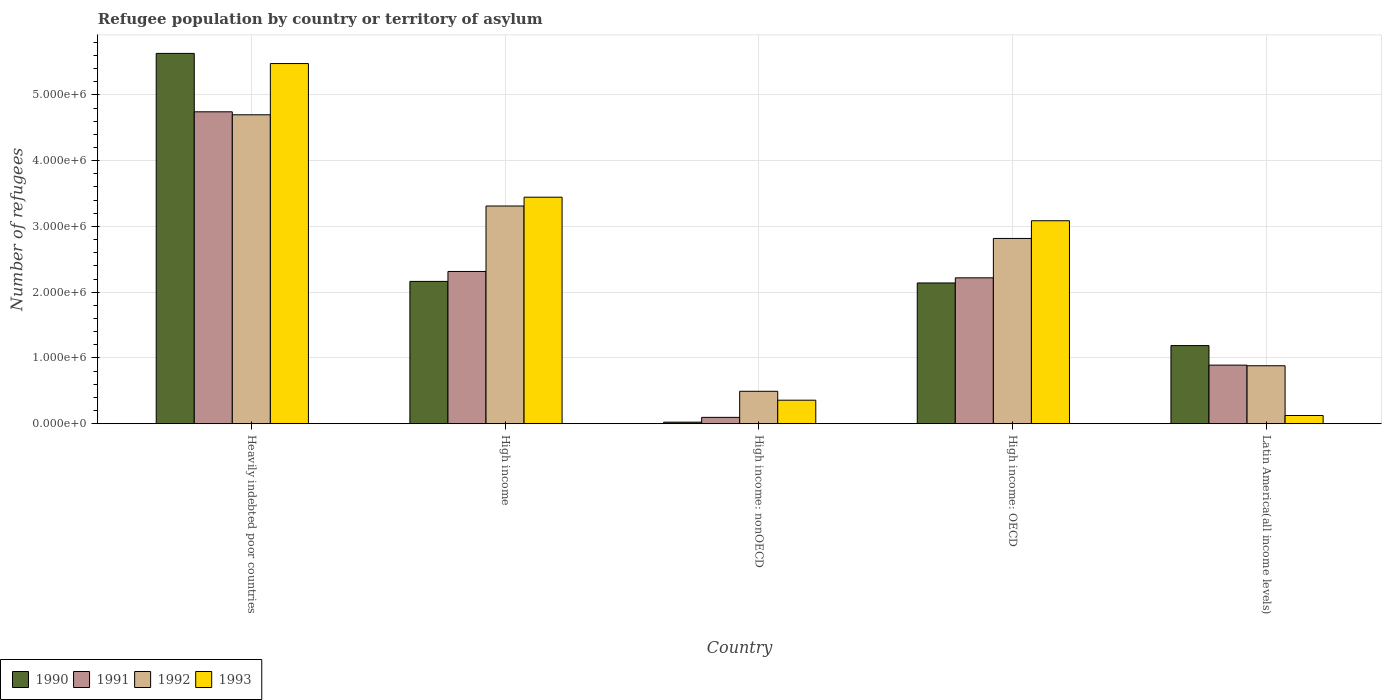Are the number of bars per tick equal to the number of legend labels?
Ensure brevity in your answer.  Yes. What is the label of the 1st group of bars from the left?
Ensure brevity in your answer.  Heavily indebted poor countries. In how many cases, is the number of bars for a given country not equal to the number of legend labels?
Your response must be concise. 0. What is the number of refugees in 1992 in Latin America(all income levels)?
Keep it short and to the point. 8.82e+05. Across all countries, what is the maximum number of refugees in 1992?
Provide a short and direct response. 4.70e+06. Across all countries, what is the minimum number of refugees in 1992?
Provide a short and direct response. 4.93e+05. In which country was the number of refugees in 1992 maximum?
Your answer should be very brief. Heavily indebted poor countries. In which country was the number of refugees in 1990 minimum?
Your answer should be compact. High income: nonOECD. What is the total number of refugees in 1991 in the graph?
Make the answer very short. 1.03e+07. What is the difference between the number of refugees in 1992 in High income: OECD and that in Latin America(all income levels)?
Offer a terse response. 1.94e+06. What is the difference between the number of refugees in 1990 in High income and the number of refugees in 1991 in Heavily indebted poor countries?
Ensure brevity in your answer.  -2.58e+06. What is the average number of refugees in 1991 per country?
Your answer should be very brief. 2.05e+06. What is the difference between the number of refugees of/in 1993 and number of refugees of/in 1991 in Heavily indebted poor countries?
Provide a short and direct response. 7.34e+05. In how many countries, is the number of refugees in 1993 greater than 1600000?
Your answer should be compact. 3. What is the ratio of the number of refugees in 1990 in High income: nonOECD to that in Latin America(all income levels)?
Your answer should be very brief. 0.02. Is the number of refugees in 1990 in High income: OECD less than that in High income: nonOECD?
Make the answer very short. No. What is the difference between the highest and the second highest number of refugees in 1991?
Ensure brevity in your answer.  -2.52e+06. What is the difference between the highest and the lowest number of refugees in 1992?
Offer a very short reply. 4.20e+06. Is the sum of the number of refugees in 1992 in High income: OECD and Latin America(all income levels) greater than the maximum number of refugees in 1990 across all countries?
Give a very brief answer. No. Is it the case that in every country, the sum of the number of refugees in 1993 and number of refugees in 1992 is greater than the sum of number of refugees in 1990 and number of refugees in 1991?
Ensure brevity in your answer.  No. What does the 1st bar from the left in High income: OECD represents?
Keep it short and to the point. 1990. Is it the case that in every country, the sum of the number of refugees in 1993 and number of refugees in 1991 is greater than the number of refugees in 1990?
Your answer should be very brief. No. Are all the bars in the graph horizontal?
Provide a succinct answer. No. How many countries are there in the graph?
Offer a terse response. 5. What is the difference between two consecutive major ticks on the Y-axis?
Provide a succinct answer. 1.00e+06. How many legend labels are there?
Provide a short and direct response. 4. How are the legend labels stacked?
Offer a terse response. Horizontal. What is the title of the graph?
Your answer should be compact. Refugee population by country or territory of asylum. Does "1995" appear as one of the legend labels in the graph?
Ensure brevity in your answer.  No. What is the label or title of the X-axis?
Provide a succinct answer. Country. What is the label or title of the Y-axis?
Ensure brevity in your answer.  Number of refugees. What is the Number of refugees of 1990 in Heavily indebted poor countries?
Your answer should be compact. 5.63e+06. What is the Number of refugees in 1991 in Heavily indebted poor countries?
Give a very brief answer. 4.74e+06. What is the Number of refugees of 1992 in Heavily indebted poor countries?
Your answer should be very brief. 4.70e+06. What is the Number of refugees of 1993 in Heavily indebted poor countries?
Ensure brevity in your answer.  5.48e+06. What is the Number of refugees of 1990 in High income?
Give a very brief answer. 2.16e+06. What is the Number of refugees of 1991 in High income?
Your answer should be compact. 2.32e+06. What is the Number of refugees in 1992 in High income?
Offer a terse response. 3.31e+06. What is the Number of refugees of 1993 in High income?
Provide a succinct answer. 3.44e+06. What is the Number of refugees of 1990 in High income: nonOECD?
Your answer should be very brief. 2.39e+04. What is the Number of refugees in 1991 in High income: nonOECD?
Give a very brief answer. 9.69e+04. What is the Number of refugees in 1992 in High income: nonOECD?
Provide a short and direct response. 4.93e+05. What is the Number of refugees of 1993 in High income: nonOECD?
Give a very brief answer. 3.58e+05. What is the Number of refugees of 1990 in High income: OECD?
Your response must be concise. 2.14e+06. What is the Number of refugees in 1991 in High income: OECD?
Provide a succinct answer. 2.22e+06. What is the Number of refugees of 1992 in High income: OECD?
Provide a succinct answer. 2.82e+06. What is the Number of refugees in 1993 in High income: OECD?
Offer a very short reply. 3.09e+06. What is the Number of refugees in 1990 in Latin America(all income levels)?
Provide a succinct answer. 1.19e+06. What is the Number of refugees in 1991 in Latin America(all income levels)?
Your response must be concise. 8.91e+05. What is the Number of refugees of 1992 in Latin America(all income levels)?
Give a very brief answer. 8.82e+05. What is the Number of refugees of 1993 in Latin America(all income levels)?
Give a very brief answer. 1.25e+05. Across all countries, what is the maximum Number of refugees in 1990?
Your answer should be very brief. 5.63e+06. Across all countries, what is the maximum Number of refugees of 1991?
Offer a terse response. 4.74e+06. Across all countries, what is the maximum Number of refugees in 1992?
Ensure brevity in your answer.  4.70e+06. Across all countries, what is the maximum Number of refugees of 1993?
Give a very brief answer. 5.48e+06. Across all countries, what is the minimum Number of refugees of 1990?
Your response must be concise. 2.39e+04. Across all countries, what is the minimum Number of refugees of 1991?
Give a very brief answer. 9.69e+04. Across all countries, what is the minimum Number of refugees in 1992?
Provide a succinct answer. 4.93e+05. Across all countries, what is the minimum Number of refugees in 1993?
Offer a terse response. 1.25e+05. What is the total Number of refugees of 1990 in the graph?
Offer a terse response. 1.11e+07. What is the total Number of refugees in 1991 in the graph?
Your response must be concise. 1.03e+07. What is the total Number of refugees in 1992 in the graph?
Ensure brevity in your answer.  1.22e+07. What is the total Number of refugees of 1993 in the graph?
Make the answer very short. 1.25e+07. What is the difference between the Number of refugees in 1990 in Heavily indebted poor countries and that in High income?
Your answer should be compact. 3.47e+06. What is the difference between the Number of refugees in 1991 in Heavily indebted poor countries and that in High income?
Provide a short and direct response. 2.43e+06. What is the difference between the Number of refugees in 1992 in Heavily indebted poor countries and that in High income?
Provide a succinct answer. 1.39e+06. What is the difference between the Number of refugees of 1993 in Heavily indebted poor countries and that in High income?
Your answer should be very brief. 2.03e+06. What is the difference between the Number of refugees in 1990 in Heavily indebted poor countries and that in High income: nonOECD?
Offer a terse response. 5.61e+06. What is the difference between the Number of refugees in 1991 in Heavily indebted poor countries and that in High income: nonOECD?
Give a very brief answer. 4.65e+06. What is the difference between the Number of refugees in 1992 in Heavily indebted poor countries and that in High income: nonOECD?
Your answer should be compact. 4.20e+06. What is the difference between the Number of refugees of 1993 in Heavily indebted poor countries and that in High income: nonOECD?
Your answer should be very brief. 5.12e+06. What is the difference between the Number of refugees of 1990 in Heavily indebted poor countries and that in High income: OECD?
Your answer should be compact. 3.49e+06. What is the difference between the Number of refugees in 1991 in Heavily indebted poor countries and that in High income: OECD?
Your answer should be compact. 2.52e+06. What is the difference between the Number of refugees of 1992 in Heavily indebted poor countries and that in High income: OECD?
Your response must be concise. 1.88e+06. What is the difference between the Number of refugees of 1993 in Heavily indebted poor countries and that in High income: OECD?
Your answer should be very brief. 2.39e+06. What is the difference between the Number of refugees of 1990 in Heavily indebted poor countries and that in Latin America(all income levels)?
Provide a succinct answer. 4.44e+06. What is the difference between the Number of refugees of 1991 in Heavily indebted poor countries and that in Latin America(all income levels)?
Provide a short and direct response. 3.85e+06. What is the difference between the Number of refugees of 1992 in Heavily indebted poor countries and that in Latin America(all income levels)?
Your response must be concise. 3.82e+06. What is the difference between the Number of refugees in 1993 in Heavily indebted poor countries and that in Latin America(all income levels)?
Give a very brief answer. 5.35e+06. What is the difference between the Number of refugees of 1990 in High income and that in High income: nonOECD?
Ensure brevity in your answer.  2.14e+06. What is the difference between the Number of refugees in 1991 in High income and that in High income: nonOECD?
Offer a very short reply. 2.22e+06. What is the difference between the Number of refugees of 1992 in High income and that in High income: nonOECD?
Ensure brevity in your answer.  2.82e+06. What is the difference between the Number of refugees in 1993 in High income and that in High income: nonOECD?
Your answer should be very brief. 3.09e+06. What is the difference between the Number of refugees in 1990 in High income and that in High income: OECD?
Provide a succinct answer. 2.39e+04. What is the difference between the Number of refugees of 1991 in High income and that in High income: OECD?
Your answer should be compact. 9.69e+04. What is the difference between the Number of refugees of 1992 in High income and that in High income: OECD?
Your answer should be very brief. 4.93e+05. What is the difference between the Number of refugees of 1993 in High income and that in High income: OECD?
Your response must be concise. 3.58e+05. What is the difference between the Number of refugees in 1990 in High income and that in Latin America(all income levels)?
Keep it short and to the point. 9.76e+05. What is the difference between the Number of refugees in 1991 in High income and that in Latin America(all income levels)?
Offer a terse response. 1.42e+06. What is the difference between the Number of refugees in 1992 in High income and that in Latin America(all income levels)?
Give a very brief answer. 2.43e+06. What is the difference between the Number of refugees in 1993 in High income and that in Latin America(all income levels)?
Offer a very short reply. 3.32e+06. What is the difference between the Number of refugees of 1990 in High income: nonOECD and that in High income: OECD?
Provide a succinct answer. -2.12e+06. What is the difference between the Number of refugees in 1991 in High income: nonOECD and that in High income: OECD?
Keep it short and to the point. -2.12e+06. What is the difference between the Number of refugees of 1992 in High income: nonOECD and that in High income: OECD?
Your answer should be very brief. -2.32e+06. What is the difference between the Number of refugees in 1993 in High income: nonOECD and that in High income: OECD?
Make the answer very short. -2.73e+06. What is the difference between the Number of refugees of 1990 in High income: nonOECD and that in Latin America(all income levels)?
Make the answer very short. -1.16e+06. What is the difference between the Number of refugees of 1991 in High income: nonOECD and that in Latin America(all income levels)?
Ensure brevity in your answer.  -7.94e+05. What is the difference between the Number of refugees of 1992 in High income: nonOECD and that in Latin America(all income levels)?
Your response must be concise. -3.88e+05. What is the difference between the Number of refugees in 1993 in High income: nonOECD and that in Latin America(all income levels)?
Your response must be concise. 2.33e+05. What is the difference between the Number of refugees in 1990 in High income: OECD and that in Latin America(all income levels)?
Keep it short and to the point. 9.52e+05. What is the difference between the Number of refugees of 1991 in High income: OECD and that in Latin America(all income levels)?
Give a very brief answer. 1.33e+06. What is the difference between the Number of refugees in 1992 in High income: OECD and that in Latin America(all income levels)?
Ensure brevity in your answer.  1.94e+06. What is the difference between the Number of refugees in 1993 in High income: OECD and that in Latin America(all income levels)?
Ensure brevity in your answer.  2.96e+06. What is the difference between the Number of refugees of 1990 in Heavily indebted poor countries and the Number of refugees of 1991 in High income?
Give a very brief answer. 3.32e+06. What is the difference between the Number of refugees of 1990 in Heavily indebted poor countries and the Number of refugees of 1992 in High income?
Your answer should be very brief. 2.32e+06. What is the difference between the Number of refugees of 1990 in Heavily indebted poor countries and the Number of refugees of 1993 in High income?
Offer a very short reply. 2.19e+06. What is the difference between the Number of refugees in 1991 in Heavily indebted poor countries and the Number of refugees in 1992 in High income?
Your response must be concise. 1.43e+06. What is the difference between the Number of refugees of 1991 in Heavily indebted poor countries and the Number of refugees of 1993 in High income?
Offer a very short reply. 1.30e+06. What is the difference between the Number of refugees of 1992 in Heavily indebted poor countries and the Number of refugees of 1993 in High income?
Provide a short and direct response. 1.25e+06. What is the difference between the Number of refugees of 1990 in Heavily indebted poor countries and the Number of refugees of 1991 in High income: nonOECD?
Provide a short and direct response. 5.53e+06. What is the difference between the Number of refugees in 1990 in Heavily indebted poor countries and the Number of refugees in 1992 in High income: nonOECD?
Offer a terse response. 5.14e+06. What is the difference between the Number of refugees of 1990 in Heavily indebted poor countries and the Number of refugees of 1993 in High income: nonOECD?
Offer a terse response. 5.27e+06. What is the difference between the Number of refugees of 1991 in Heavily indebted poor countries and the Number of refugees of 1992 in High income: nonOECD?
Your response must be concise. 4.25e+06. What is the difference between the Number of refugees of 1991 in Heavily indebted poor countries and the Number of refugees of 1993 in High income: nonOECD?
Offer a terse response. 4.38e+06. What is the difference between the Number of refugees of 1992 in Heavily indebted poor countries and the Number of refugees of 1993 in High income: nonOECD?
Your answer should be very brief. 4.34e+06. What is the difference between the Number of refugees of 1990 in Heavily indebted poor countries and the Number of refugees of 1991 in High income: OECD?
Offer a very short reply. 3.41e+06. What is the difference between the Number of refugees of 1990 in Heavily indebted poor countries and the Number of refugees of 1992 in High income: OECD?
Offer a very short reply. 2.81e+06. What is the difference between the Number of refugees in 1990 in Heavily indebted poor countries and the Number of refugees in 1993 in High income: OECD?
Give a very brief answer. 2.54e+06. What is the difference between the Number of refugees of 1991 in Heavily indebted poor countries and the Number of refugees of 1992 in High income: OECD?
Offer a terse response. 1.93e+06. What is the difference between the Number of refugees in 1991 in Heavily indebted poor countries and the Number of refugees in 1993 in High income: OECD?
Your answer should be compact. 1.66e+06. What is the difference between the Number of refugees in 1992 in Heavily indebted poor countries and the Number of refugees in 1993 in High income: OECD?
Ensure brevity in your answer.  1.61e+06. What is the difference between the Number of refugees of 1990 in Heavily indebted poor countries and the Number of refugees of 1991 in Latin America(all income levels)?
Your answer should be compact. 4.74e+06. What is the difference between the Number of refugees of 1990 in Heavily indebted poor countries and the Number of refugees of 1992 in Latin America(all income levels)?
Give a very brief answer. 4.75e+06. What is the difference between the Number of refugees of 1990 in Heavily indebted poor countries and the Number of refugees of 1993 in Latin America(all income levels)?
Offer a terse response. 5.51e+06. What is the difference between the Number of refugees in 1991 in Heavily indebted poor countries and the Number of refugees in 1992 in Latin America(all income levels)?
Provide a succinct answer. 3.86e+06. What is the difference between the Number of refugees of 1991 in Heavily indebted poor countries and the Number of refugees of 1993 in Latin America(all income levels)?
Ensure brevity in your answer.  4.62e+06. What is the difference between the Number of refugees in 1992 in Heavily indebted poor countries and the Number of refugees in 1993 in Latin America(all income levels)?
Keep it short and to the point. 4.57e+06. What is the difference between the Number of refugees in 1990 in High income and the Number of refugees in 1991 in High income: nonOECD?
Your answer should be compact. 2.07e+06. What is the difference between the Number of refugees of 1990 in High income and the Number of refugees of 1992 in High income: nonOECD?
Provide a succinct answer. 1.67e+06. What is the difference between the Number of refugees in 1990 in High income and the Number of refugees in 1993 in High income: nonOECD?
Your answer should be compact. 1.81e+06. What is the difference between the Number of refugees of 1991 in High income and the Number of refugees of 1992 in High income: nonOECD?
Your answer should be very brief. 1.82e+06. What is the difference between the Number of refugees of 1991 in High income and the Number of refugees of 1993 in High income: nonOECD?
Provide a succinct answer. 1.96e+06. What is the difference between the Number of refugees of 1992 in High income and the Number of refugees of 1993 in High income: nonOECD?
Your answer should be very brief. 2.95e+06. What is the difference between the Number of refugees in 1990 in High income and the Number of refugees in 1991 in High income: OECD?
Offer a terse response. -5.41e+04. What is the difference between the Number of refugees in 1990 in High income and the Number of refugees in 1992 in High income: OECD?
Your answer should be very brief. -6.53e+05. What is the difference between the Number of refugees in 1990 in High income and the Number of refugees in 1993 in High income: OECD?
Make the answer very short. -9.22e+05. What is the difference between the Number of refugees of 1991 in High income and the Number of refugees of 1992 in High income: OECD?
Offer a terse response. -5.02e+05. What is the difference between the Number of refugees in 1991 in High income and the Number of refugees in 1993 in High income: OECD?
Provide a succinct answer. -7.71e+05. What is the difference between the Number of refugees in 1992 in High income and the Number of refugees in 1993 in High income: OECD?
Keep it short and to the point. 2.24e+05. What is the difference between the Number of refugees in 1990 in High income and the Number of refugees in 1991 in Latin America(all income levels)?
Provide a succinct answer. 1.27e+06. What is the difference between the Number of refugees in 1990 in High income and the Number of refugees in 1992 in Latin America(all income levels)?
Your answer should be very brief. 1.28e+06. What is the difference between the Number of refugees in 1990 in High income and the Number of refugees in 1993 in Latin America(all income levels)?
Provide a short and direct response. 2.04e+06. What is the difference between the Number of refugees in 1991 in High income and the Number of refugees in 1992 in Latin America(all income levels)?
Offer a very short reply. 1.43e+06. What is the difference between the Number of refugees of 1991 in High income and the Number of refugees of 1993 in Latin America(all income levels)?
Offer a very short reply. 2.19e+06. What is the difference between the Number of refugees of 1992 in High income and the Number of refugees of 1993 in Latin America(all income levels)?
Your answer should be compact. 3.19e+06. What is the difference between the Number of refugees in 1990 in High income: nonOECD and the Number of refugees in 1991 in High income: OECD?
Your answer should be very brief. -2.19e+06. What is the difference between the Number of refugees in 1990 in High income: nonOECD and the Number of refugees in 1992 in High income: OECD?
Your answer should be compact. -2.79e+06. What is the difference between the Number of refugees in 1990 in High income: nonOECD and the Number of refugees in 1993 in High income: OECD?
Your answer should be very brief. -3.06e+06. What is the difference between the Number of refugees in 1991 in High income: nonOECD and the Number of refugees in 1992 in High income: OECD?
Offer a terse response. -2.72e+06. What is the difference between the Number of refugees of 1991 in High income: nonOECD and the Number of refugees of 1993 in High income: OECD?
Your answer should be very brief. -2.99e+06. What is the difference between the Number of refugees of 1992 in High income: nonOECD and the Number of refugees of 1993 in High income: OECD?
Provide a short and direct response. -2.59e+06. What is the difference between the Number of refugees of 1990 in High income: nonOECD and the Number of refugees of 1991 in Latin America(all income levels)?
Keep it short and to the point. -8.67e+05. What is the difference between the Number of refugees in 1990 in High income: nonOECD and the Number of refugees in 1992 in Latin America(all income levels)?
Your response must be concise. -8.58e+05. What is the difference between the Number of refugees in 1990 in High income: nonOECD and the Number of refugees in 1993 in Latin America(all income levels)?
Offer a very short reply. -1.01e+05. What is the difference between the Number of refugees of 1991 in High income: nonOECD and the Number of refugees of 1992 in Latin America(all income levels)?
Keep it short and to the point. -7.85e+05. What is the difference between the Number of refugees of 1991 in High income: nonOECD and the Number of refugees of 1993 in Latin America(all income levels)?
Offer a very short reply. -2.83e+04. What is the difference between the Number of refugees of 1992 in High income: nonOECD and the Number of refugees of 1993 in Latin America(all income levels)?
Your answer should be very brief. 3.68e+05. What is the difference between the Number of refugees of 1990 in High income: OECD and the Number of refugees of 1991 in Latin America(all income levels)?
Keep it short and to the point. 1.25e+06. What is the difference between the Number of refugees in 1990 in High income: OECD and the Number of refugees in 1992 in Latin America(all income levels)?
Offer a very short reply. 1.26e+06. What is the difference between the Number of refugees in 1990 in High income: OECD and the Number of refugees in 1993 in Latin America(all income levels)?
Keep it short and to the point. 2.02e+06. What is the difference between the Number of refugees in 1991 in High income: OECD and the Number of refugees in 1992 in Latin America(all income levels)?
Give a very brief answer. 1.34e+06. What is the difference between the Number of refugees of 1991 in High income: OECD and the Number of refugees of 1993 in Latin America(all income levels)?
Your answer should be compact. 2.09e+06. What is the difference between the Number of refugees of 1992 in High income: OECD and the Number of refugees of 1993 in Latin America(all income levels)?
Make the answer very short. 2.69e+06. What is the average Number of refugees in 1990 per country?
Provide a succinct answer. 2.23e+06. What is the average Number of refugees of 1991 per country?
Offer a terse response. 2.05e+06. What is the average Number of refugees in 1992 per country?
Keep it short and to the point. 2.44e+06. What is the average Number of refugees in 1993 per country?
Offer a terse response. 2.50e+06. What is the difference between the Number of refugees in 1990 and Number of refugees in 1991 in Heavily indebted poor countries?
Provide a short and direct response. 8.88e+05. What is the difference between the Number of refugees of 1990 and Number of refugees of 1992 in Heavily indebted poor countries?
Offer a very short reply. 9.34e+05. What is the difference between the Number of refugees of 1990 and Number of refugees of 1993 in Heavily indebted poor countries?
Offer a very short reply. 1.54e+05. What is the difference between the Number of refugees in 1991 and Number of refugees in 1992 in Heavily indebted poor countries?
Your answer should be compact. 4.54e+04. What is the difference between the Number of refugees of 1991 and Number of refugees of 1993 in Heavily indebted poor countries?
Offer a terse response. -7.34e+05. What is the difference between the Number of refugees of 1992 and Number of refugees of 1993 in Heavily indebted poor countries?
Provide a short and direct response. -7.79e+05. What is the difference between the Number of refugees in 1990 and Number of refugees in 1991 in High income?
Provide a short and direct response. -1.51e+05. What is the difference between the Number of refugees in 1990 and Number of refugees in 1992 in High income?
Give a very brief answer. -1.15e+06. What is the difference between the Number of refugees of 1990 and Number of refugees of 1993 in High income?
Provide a short and direct response. -1.28e+06. What is the difference between the Number of refugees of 1991 and Number of refugees of 1992 in High income?
Your response must be concise. -9.95e+05. What is the difference between the Number of refugees of 1991 and Number of refugees of 1993 in High income?
Keep it short and to the point. -1.13e+06. What is the difference between the Number of refugees in 1992 and Number of refugees in 1993 in High income?
Your answer should be very brief. -1.34e+05. What is the difference between the Number of refugees of 1990 and Number of refugees of 1991 in High income: nonOECD?
Make the answer very short. -7.30e+04. What is the difference between the Number of refugees in 1990 and Number of refugees in 1992 in High income: nonOECD?
Your response must be concise. -4.69e+05. What is the difference between the Number of refugees of 1990 and Number of refugees of 1993 in High income: nonOECD?
Make the answer very short. -3.34e+05. What is the difference between the Number of refugees in 1991 and Number of refugees in 1992 in High income: nonOECD?
Keep it short and to the point. -3.96e+05. What is the difference between the Number of refugees in 1991 and Number of refugees in 1993 in High income: nonOECD?
Offer a very short reply. -2.61e+05. What is the difference between the Number of refugees of 1992 and Number of refugees of 1993 in High income: nonOECD?
Provide a succinct answer. 1.35e+05. What is the difference between the Number of refugees of 1990 and Number of refugees of 1991 in High income: OECD?
Provide a succinct answer. -7.80e+04. What is the difference between the Number of refugees in 1990 and Number of refugees in 1992 in High income: OECD?
Your answer should be very brief. -6.77e+05. What is the difference between the Number of refugees in 1990 and Number of refugees in 1993 in High income: OECD?
Your answer should be very brief. -9.46e+05. What is the difference between the Number of refugees of 1991 and Number of refugees of 1992 in High income: OECD?
Keep it short and to the point. -5.99e+05. What is the difference between the Number of refugees in 1991 and Number of refugees in 1993 in High income: OECD?
Make the answer very short. -8.68e+05. What is the difference between the Number of refugees of 1992 and Number of refugees of 1993 in High income: OECD?
Make the answer very short. -2.69e+05. What is the difference between the Number of refugees of 1990 and Number of refugees of 1991 in Latin America(all income levels)?
Your answer should be compact. 2.97e+05. What is the difference between the Number of refugees of 1990 and Number of refugees of 1992 in Latin America(all income levels)?
Provide a succinct answer. 3.07e+05. What is the difference between the Number of refugees of 1990 and Number of refugees of 1993 in Latin America(all income levels)?
Keep it short and to the point. 1.06e+06. What is the difference between the Number of refugees of 1991 and Number of refugees of 1992 in Latin America(all income levels)?
Make the answer very short. 9437. What is the difference between the Number of refugees of 1991 and Number of refugees of 1993 in Latin America(all income levels)?
Your answer should be compact. 7.66e+05. What is the difference between the Number of refugees in 1992 and Number of refugees in 1993 in Latin America(all income levels)?
Provide a short and direct response. 7.56e+05. What is the ratio of the Number of refugees in 1990 in Heavily indebted poor countries to that in High income?
Keep it short and to the point. 2.6. What is the ratio of the Number of refugees in 1991 in Heavily indebted poor countries to that in High income?
Offer a very short reply. 2.05. What is the ratio of the Number of refugees in 1992 in Heavily indebted poor countries to that in High income?
Your answer should be compact. 1.42. What is the ratio of the Number of refugees in 1993 in Heavily indebted poor countries to that in High income?
Provide a succinct answer. 1.59. What is the ratio of the Number of refugees in 1990 in Heavily indebted poor countries to that in High income: nonOECD?
Ensure brevity in your answer.  235.63. What is the ratio of the Number of refugees in 1991 in Heavily indebted poor countries to that in High income: nonOECD?
Give a very brief answer. 48.93. What is the ratio of the Number of refugees in 1992 in Heavily indebted poor countries to that in High income: nonOECD?
Make the answer very short. 9.52. What is the ratio of the Number of refugees in 1993 in Heavily indebted poor countries to that in High income: nonOECD?
Ensure brevity in your answer.  15.3. What is the ratio of the Number of refugees of 1990 in Heavily indebted poor countries to that in High income: OECD?
Your answer should be compact. 2.63. What is the ratio of the Number of refugees in 1991 in Heavily indebted poor countries to that in High income: OECD?
Your answer should be very brief. 2.14. What is the ratio of the Number of refugees in 1992 in Heavily indebted poor countries to that in High income: OECD?
Give a very brief answer. 1.67. What is the ratio of the Number of refugees of 1993 in Heavily indebted poor countries to that in High income: OECD?
Give a very brief answer. 1.77. What is the ratio of the Number of refugees in 1990 in Heavily indebted poor countries to that in Latin America(all income levels)?
Your answer should be very brief. 4.74. What is the ratio of the Number of refugees of 1991 in Heavily indebted poor countries to that in Latin America(all income levels)?
Provide a short and direct response. 5.32. What is the ratio of the Number of refugees of 1992 in Heavily indebted poor countries to that in Latin America(all income levels)?
Your answer should be compact. 5.33. What is the ratio of the Number of refugees of 1993 in Heavily indebted poor countries to that in Latin America(all income levels)?
Provide a succinct answer. 43.71. What is the ratio of the Number of refugees of 1990 in High income to that in High income: nonOECD?
Ensure brevity in your answer.  90.57. What is the ratio of the Number of refugees of 1991 in High income to that in High income: nonOECD?
Make the answer very short. 23.88. What is the ratio of the Number of refugees in 1992 in High income to that in High income: nonOECD?
Make the answer very short. 6.71. What is the ratio of the Number of refugees of 1993 in High income to that in High income: nonOECD?
Keep it short and to the point. 9.62. What is the ratio of the Number of refugees of 1990 in High income to that in High income: OECD?
Give a very brief answer. 1.01. What is the ratio of the Number of refugees in 1991 in High income to that in High income: OECD?
Make the answer very short. 1.04. What is the ratio of the Number of refugees in 1992 in High income to that in High income: OECD?
Your response must be concise. 1.18. What is the ratio of the Number of refugees of 1993 in High income to that in High income: OECD?
Your answer should be compact. 1.12. What is the ratio of the Number of refugees of 1990 in High income to that in Latin America(all income levels)?
Give a very brief answer. 1.82. What is the ratio of the Number of refugees in 1991 in High income to that in Latin America(all income levels)?
Your answer should be very brief. 2.6. What is the ratio of the Number of refugees in 1992 in High income to that in Latin America(all income levels)?
Ensure brevity in your answer.  3.76. What is the ratio of the Number of refugees in 1993 in High income to that in Latin America(all income levels)?
Your answer should be very brief. 27.49. What is the ratio of the Number of refugees of 1990 in High income: nonOECD to that in High income: OECD?
Your answer should be compact. 0.01. What is the ratio of the Number of refugees in 1991 in High income: nonOECD to that in High income: OECD?
Keep it short and to the point. 0.04. What is the ratio of the Number of refugees in 1992 in High income: nonOECD to that in High income: OECD?
Give a very brief answer. 0.18. What is the ratio of the Number of refugees of 1993 in High income: nonOECD to that in High income: OECD?
Keep it short and to the point. 0.12. What is the ratio of the Number of refugees in 1990 in High income: nonOECD to that in Latin America(all income levels)?
Your response must be concise. 0.02. What is the ratio of the Number of refugees of 1991 in High income: nonOECD to that in Latin America(all income levels)?
Make the answer very short. 0.11. What is the ratio of the Number of refugees in 1992 in High income: nonOECD to that in Latin America(all income levels)?
Keep it short and to the point. 0.56. What is the ratio of the Number of refugees of 1993 in High income: nonOECD to that in Latin America(all income levels)?
Keep it short and to the point. 2.86. What is the ratio of the Number of refugees in 1990 in High income: OECD to that in Latin America(all income levels)?
Provide a short and direct response. 1.8. What is the ratio of the Number of refugees of 1991 in High income: OECD to that in Latin America(all income levels)?
Your answer should be very brief. 2.49. What is the ratio of the Number of refugees of 1992 in High income: OECD to that in Latin America(all income levels)?
Offer a terse response. 3.2. What is the ratio of the Number of refugees in 1993 in High income: OECD to that in Latin America(all income levels)?
Ensure brevity in your answer.  24.64. What is the difference between the highest and the second highest Number of refugees of 1990?
Ensure brevity in your answer.  3.47e+06. What is the difference between the highest and the second highest Number of refugees of 1991?
Your answer should be very brief. 2.43e+06. What is the difference between the highest and the second highest Number of refugees of 1992?
Your answer should be compact. 1.39e+06. What is the difference between the highest and the second highest Number of refugees of 1993?
Provide a succinct answer. 2.03e+06. What is the difference between the highest and the lowest Number of refugees in 1990?
Your answer should be compact. 5.61e+06. What is the difference between the highest and the lowest Number of refugees of 1991?
Your response must be concise. 4.65e+06. What is the difference between the highest and the lowest Number of refugees of 1992?
Give a very brief answer. 4.20e+06. What is the difference between the highest and the lowest Number of refugees in 1993?
Your response must be concise. 5.35e+06. 